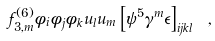<formula> <loc_0><loc_0><loc_500><loc_500>f _ { 3 , m } ^ { ( 6 ) } \phi _ { i } \phi _ { j } \phi _ { k } u _ { l } u _ { m } \left [ \psi ^ { 5 } \gamma ^ { m } \epsilon \right ] _ { i j k l } \ ,</formula> 